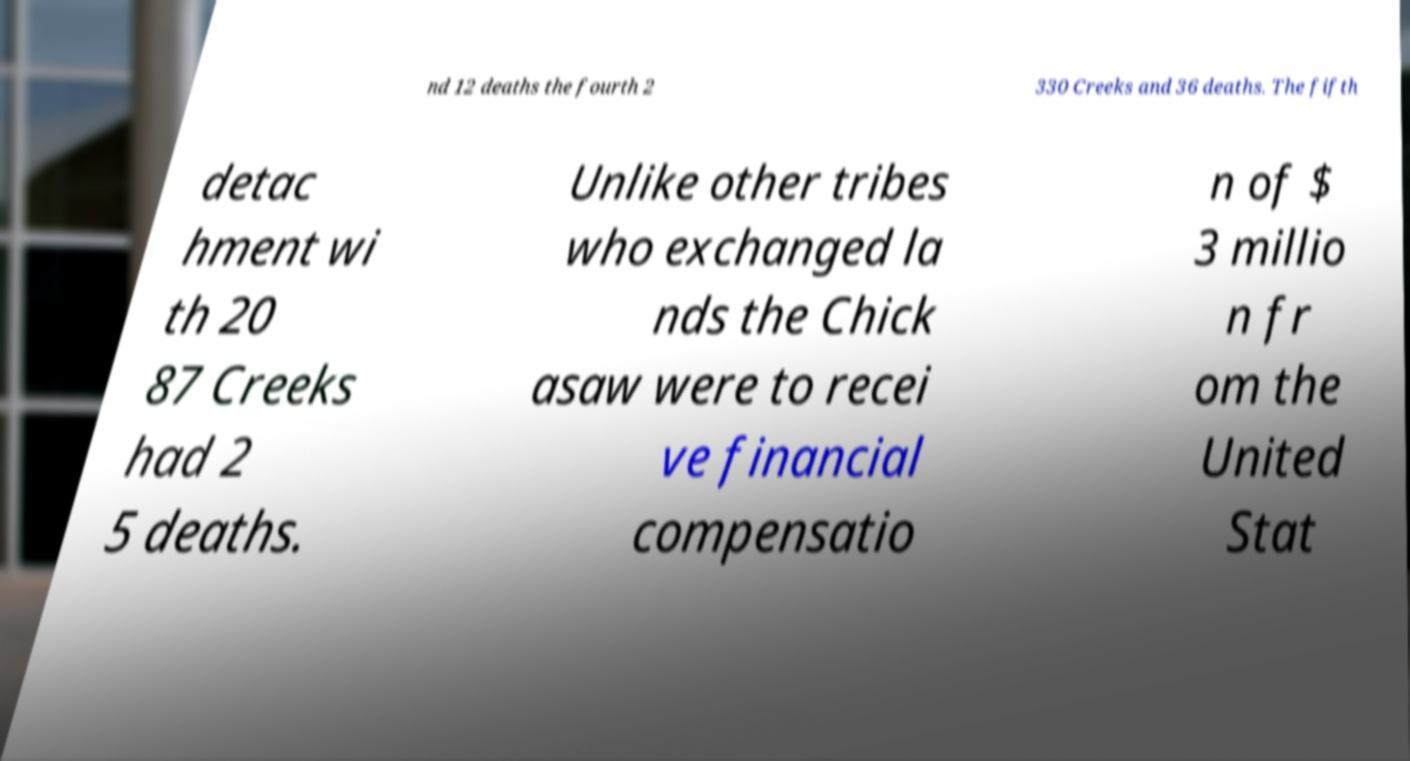Please read and relay the text visible in this image. What does it say? nd 12 deaths the fourth 2 330 Creeks and 36 deaths. The fifth detac hment wi th 20 87 Creeks had 2 5 deaths. Unlike other tribes who exchanged la nds the Chick asaw were to recei ve financial compensatio n of $ 3 millio n fr om the United Stat 